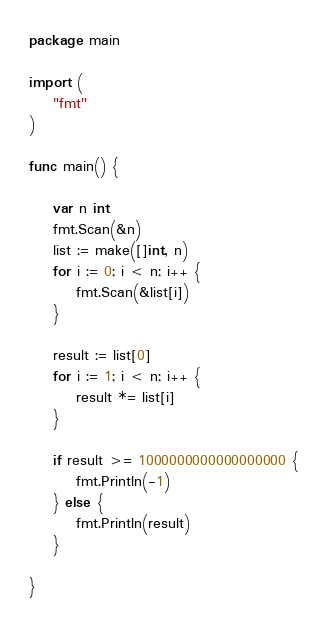Convert code to text. <code><loc_0><loc_0><loc_500><loc_500><_Go_>package main

import (
	"fmt"
)

func main() {

	var n int
	fmt.Scan(&n)
	list := make([]int, n)
	for i := 0; i < n; i++ {
		fmt.Scan(&list[i])
	}

	result := list[0]
	for i := 1; i < n; i++ {
		result *= list[i]
	}

	if result >= 1000000000000000000 {
		fmt.Println(-1)
	} else {
		fmt.Println(result)
	}

}
</code> 